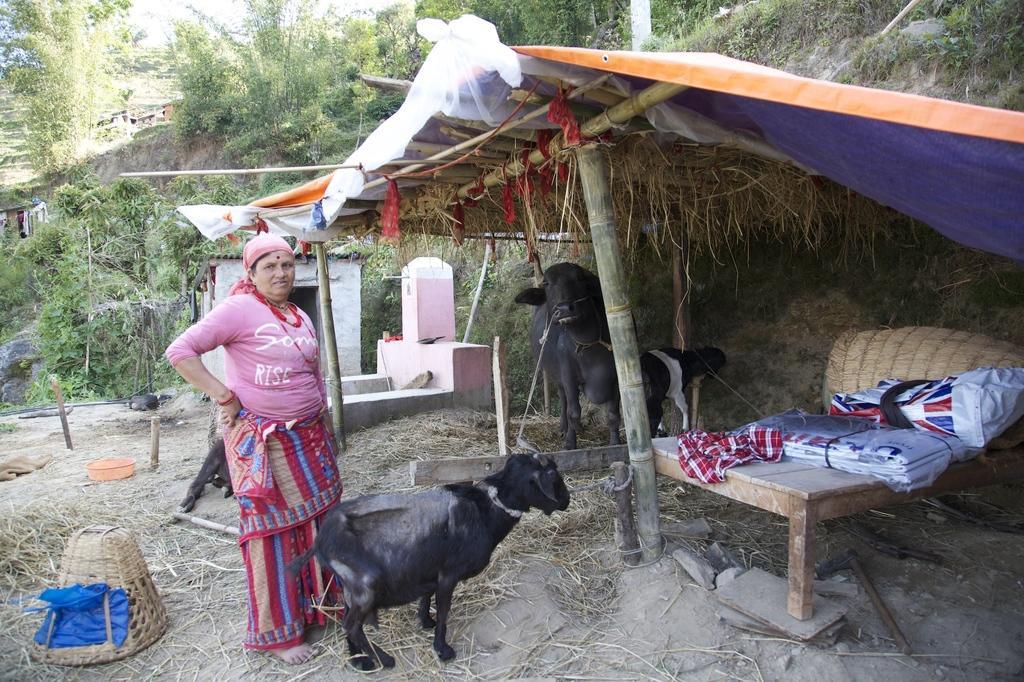Could you give a brief overview of what you see in this image? In this image I can see a person is standing and few animals in black and white color. I can see houses, shed, wooden bed and few objects on it. I can see basket, trees, tap, grass and few objects on the ground. 